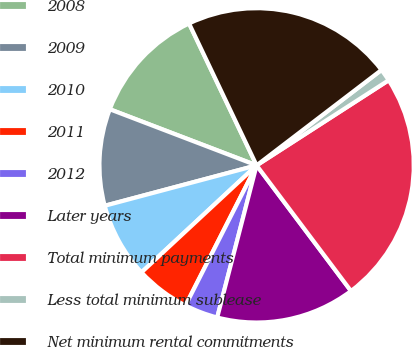Convert chart. <chart><loc_0><loc_0><loc_500><loc_500><pie_chart><fcel>2008<fcel>2009<fcel>2010<fcel>2011<fcel>2012<fcel>Later years<fcel>Total minimum payments<fcel>Less total minimum sublease<fcel>Net minimum rental commitments<nl><fcel>12.12%<fcel>9.95%<fcel>7.78%<fcel>5.61%<fcel>3.44%<fcel>14.29%<fcel>23.86%<fcel>1.27%<fcel>21.69%<nl></chart> 